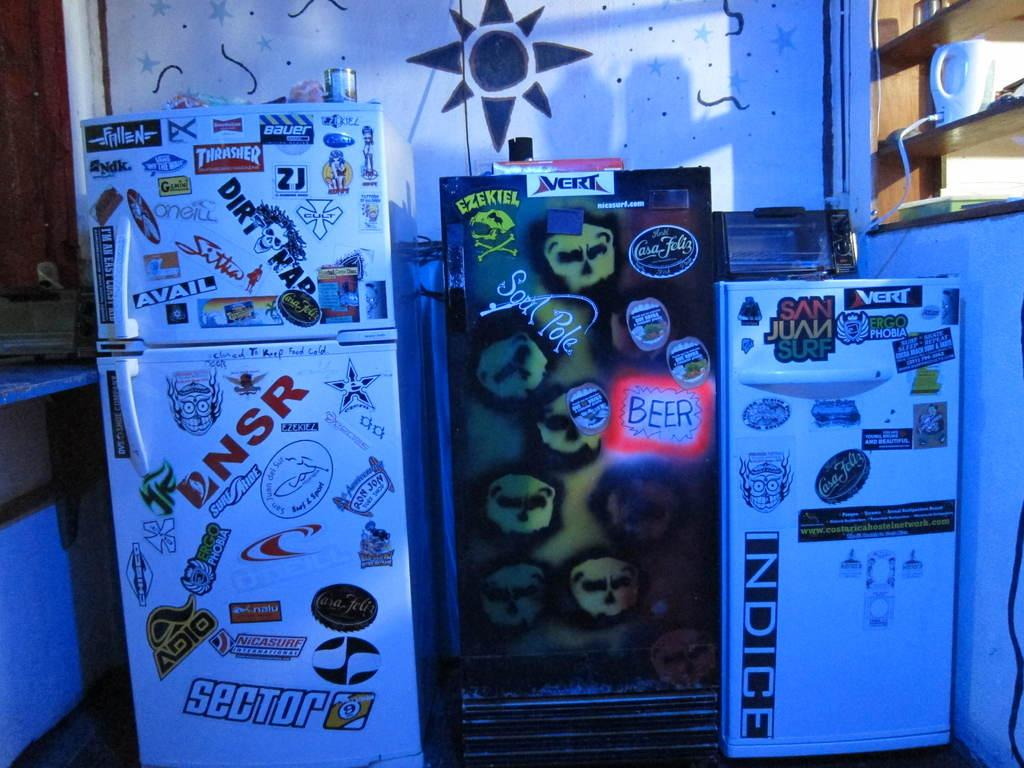<image>
Create a compact narrative representing the image presented. Three fridges next to one another with one that says INDICE on it. 